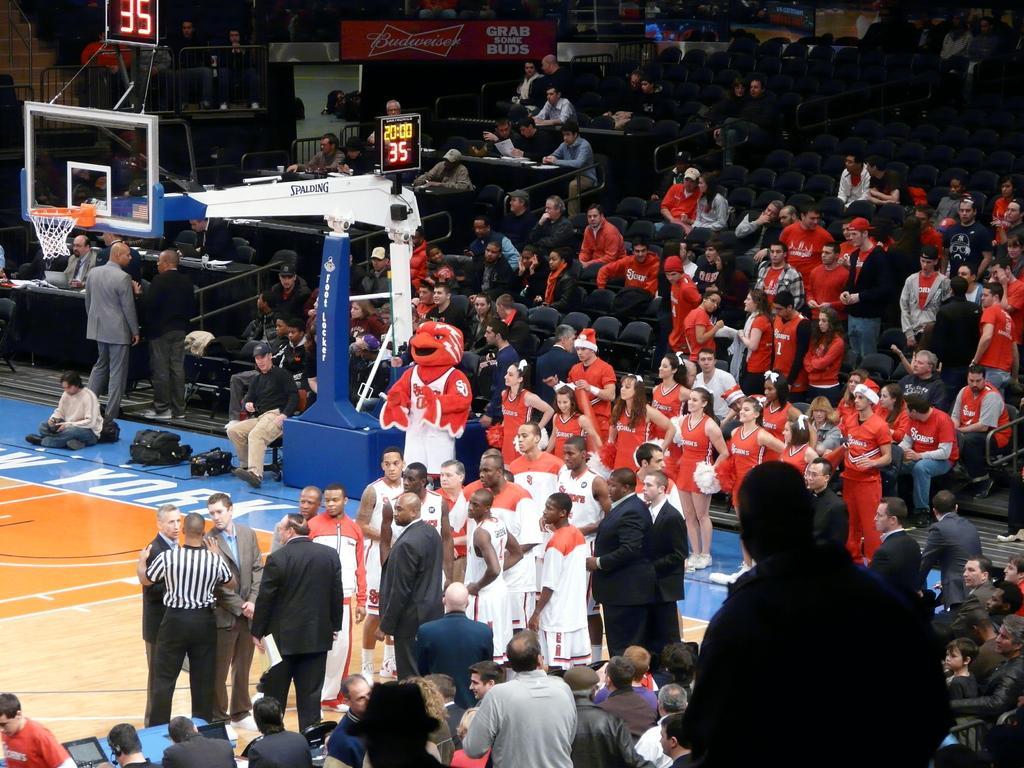Can you describe this image briefly? There is a volleyball court on the left side of this image and there are some persons standing and there are some persons sitting on the chairs as we can see on the right side of this image. 